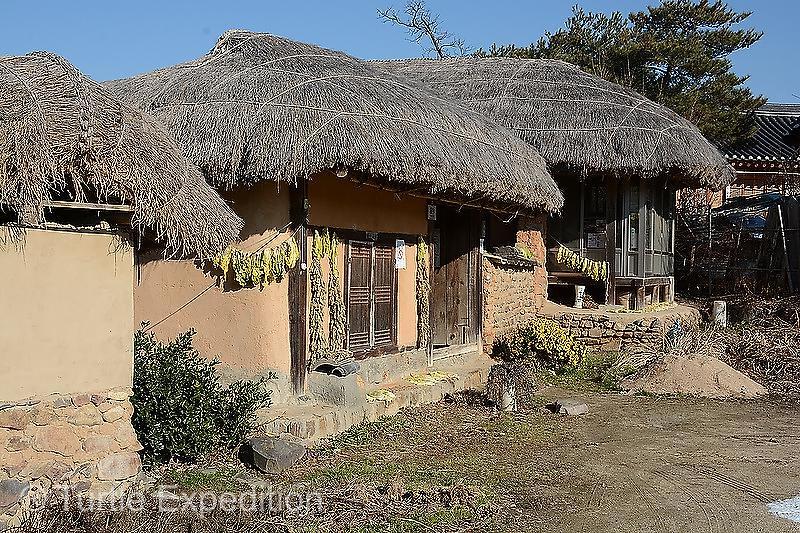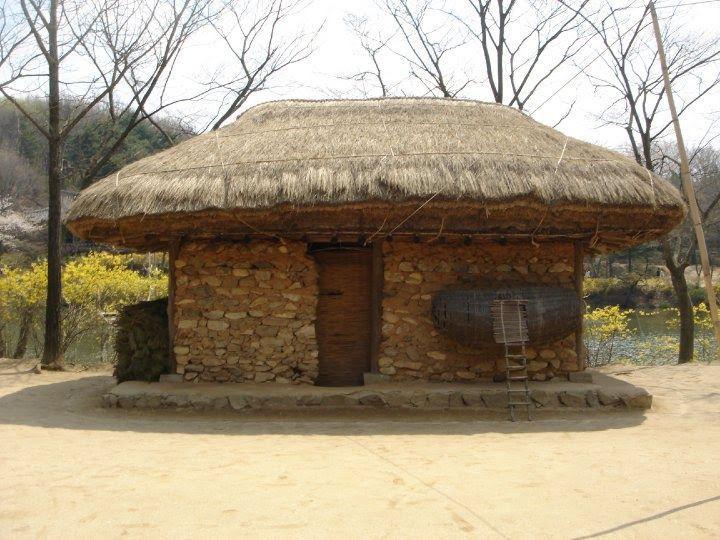The first image is the image on the left, the second image is the image on the right. For the images displayed, is the sentence "The left image shows a rock wall around at least one squarish building with smooth beige walls and a slightly peaked thatched roof." factually correct? Answer yes or no. No. 